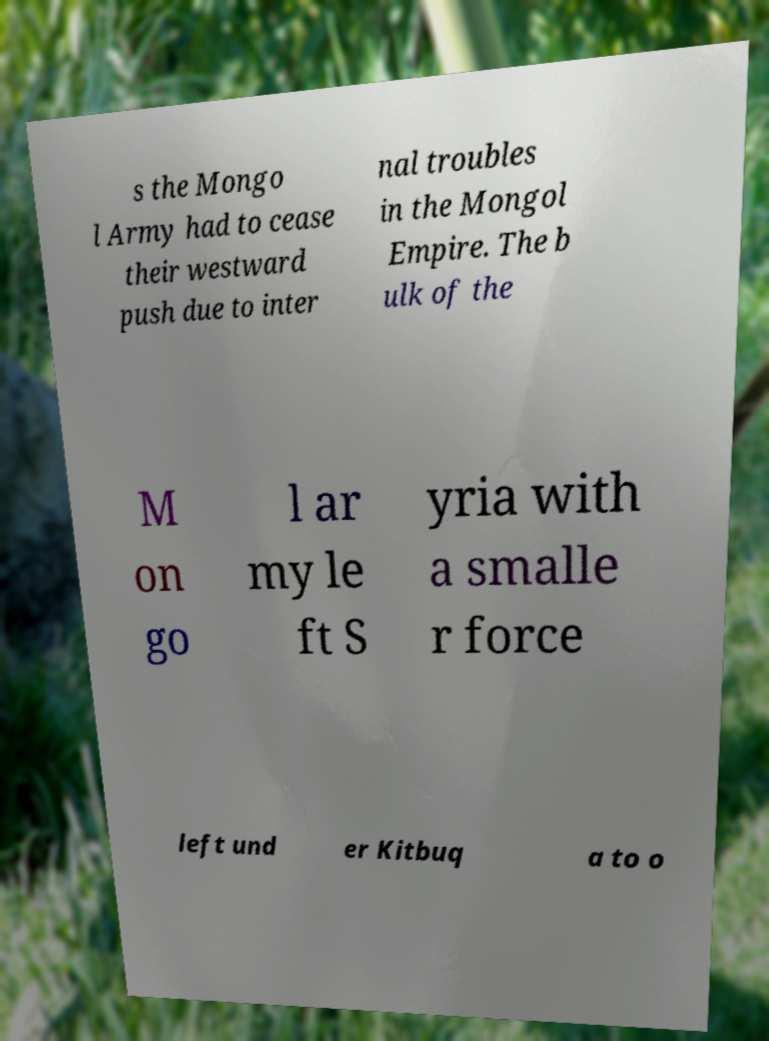Please read and relay the text visible in this image. What does it say? s the Mongo l Army had to cease their westward push due to inter nal troubles in the Mongol Empire. The b ulk of the M on go l ar my le ft S yria with a smalle r force left und er Kitbuq a to o 